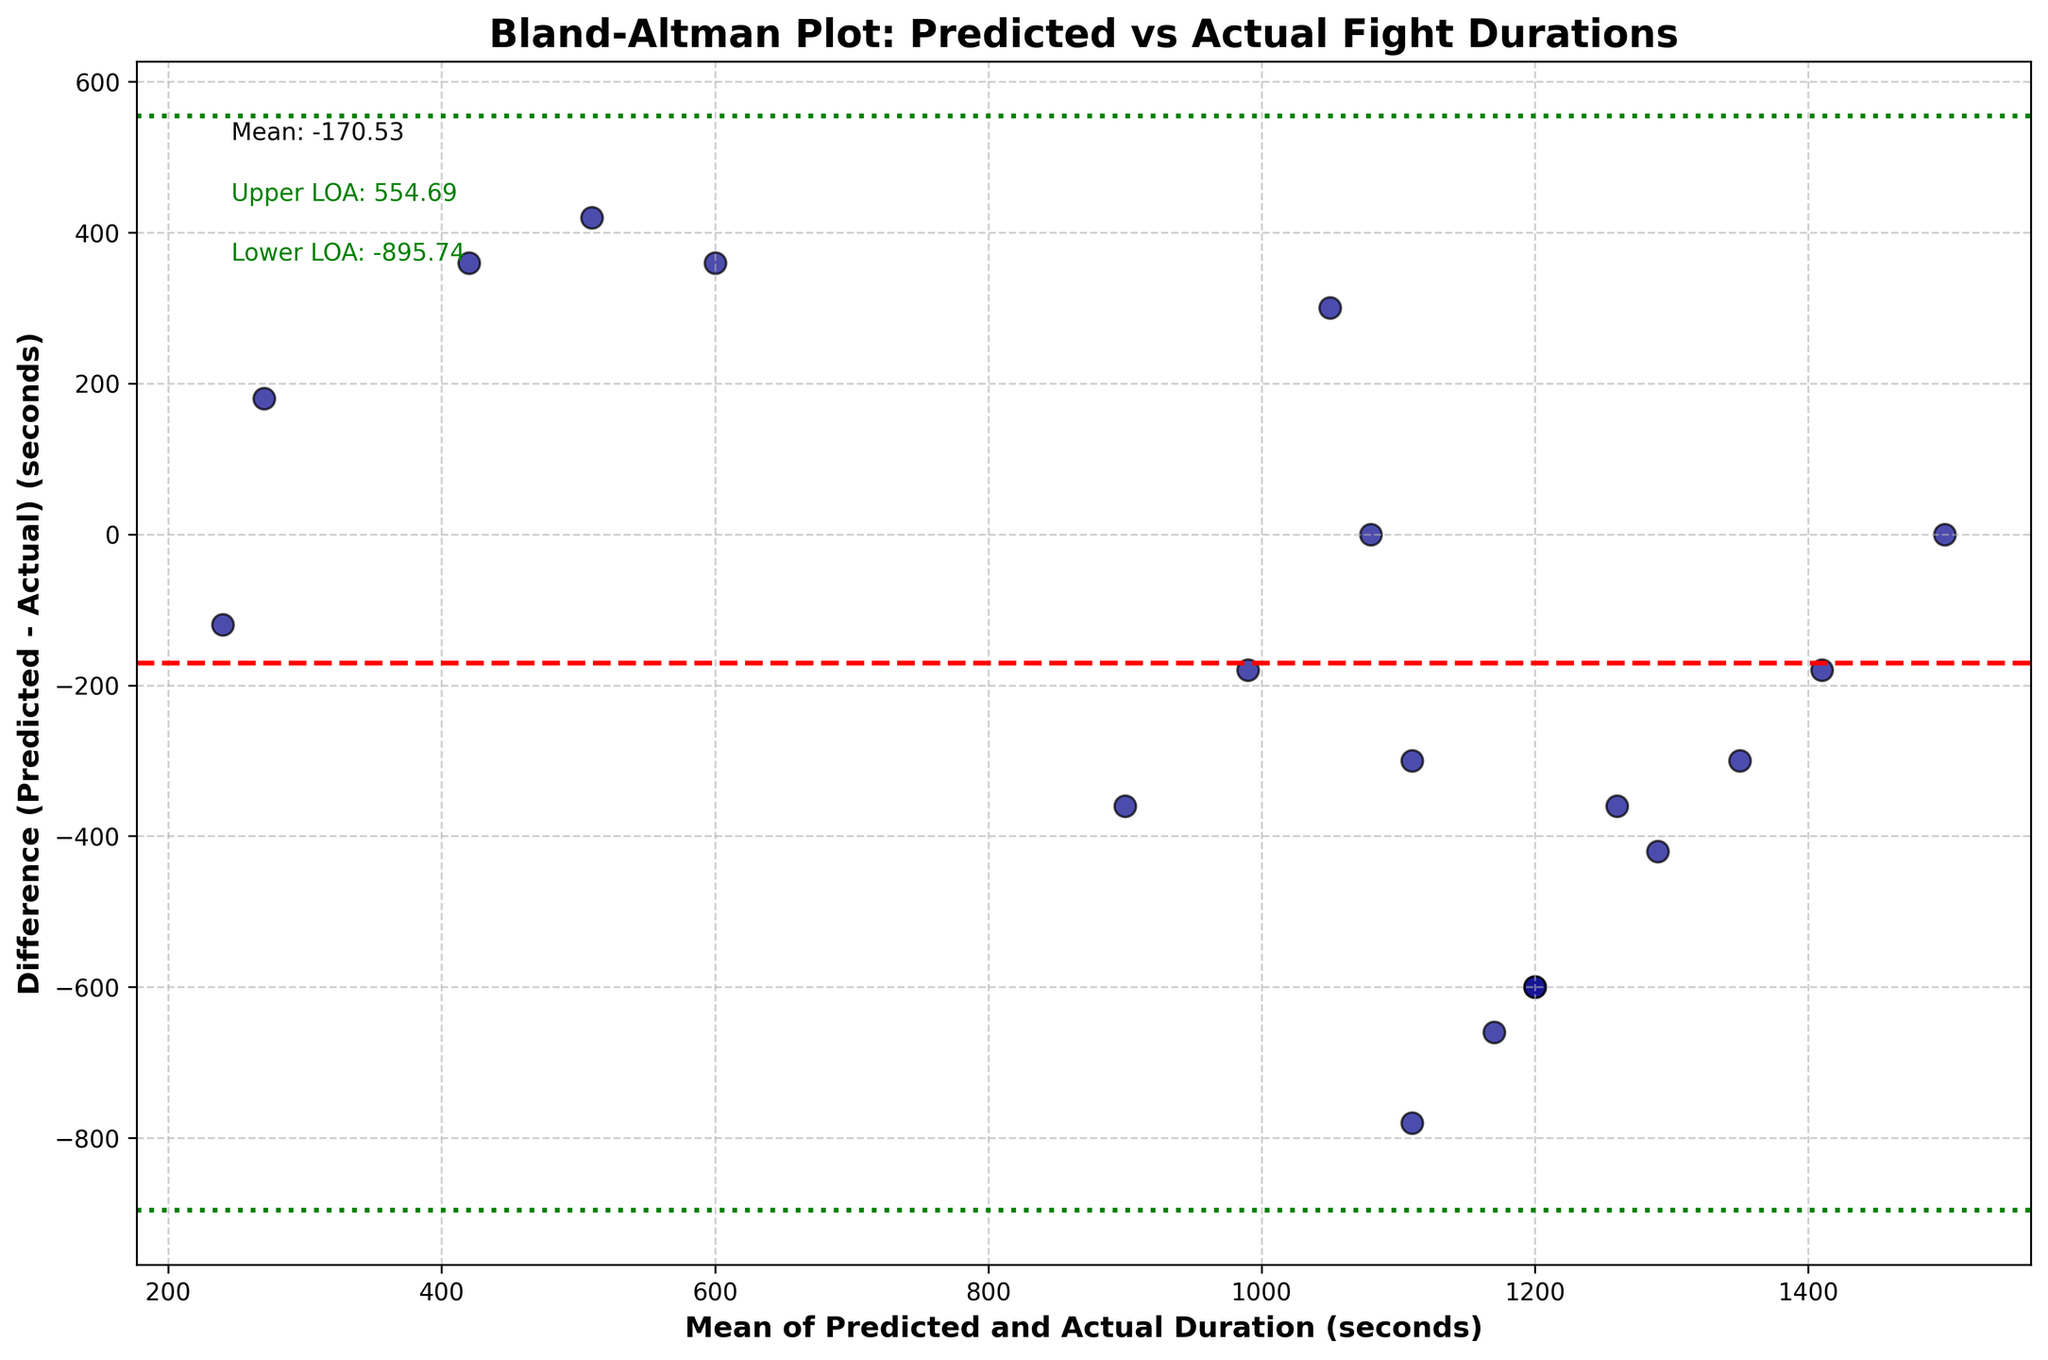How many data points are represented in the plot? Count the number of data points (scatter points) depicted in the Bland-Altman plot. Each scatter point represents a data point from the dataset.
Answer: 18 What is the title of the plot? Look at the top of the plot where the title is mentioned.
Answer: Bland-Altman Plot: Predicted vs Actual Fight Durations What does the red dashed line represent in the plot? Identify the colored lines and understand what they represent based on common conventions and annotations in Bland-Altman plots. The red dashed line typically represents the mean difference.
Answer: Mean difference Between the predicted and actual durations, what is the general trend of the differences? Observe the scatter points relative to the x-axis and determine if there is a visible pattern or trend.
Answer: There is no consistent trend, points are scattered What are the colors used for the points on the plot? The color used to plot the data (typically described in the legend or observable in the plot).
Answer: Dark blue with black edges What are the upper and lower limits of agreement (LOA)? Identify the limits of agreement from the plot annotations for better clinical interpretation. These represent ±1.96 standard deviations from the mean difference.
Answer: Upper LOA: 793.19, Lower LOA: - 675.30 Which fighter's bout had the largest difference between predicted and actual durations? By observing the spread of points on the y-axis, determine which point is the furthest from the x-axis, indicating the largest difference.
Answer: Maximum difference is 660 (Zhang Weili and Petr Yan) Does any point lie on the mean difference line? Check if any scatter points lie exactly on the red dashed line which represents the mean difference.
Answer: No Which data point corresponds to a negative difference? Observe the y-axis values and identify points below the x-axis, indicating negative differences where the actual duration was higher than predicted.
Answer: Examples: Conor McGregor (Lightweight), Amanda Nunes (Featherweight) Is there any weight class where all data points lie within the LOA? By categorizing points based on their weight classes, confirm whether the points of any specific weight class fall entirely within the green dotted lines which represent the LOA.
Answer: No, not all points of any single weight class lie within LOA 